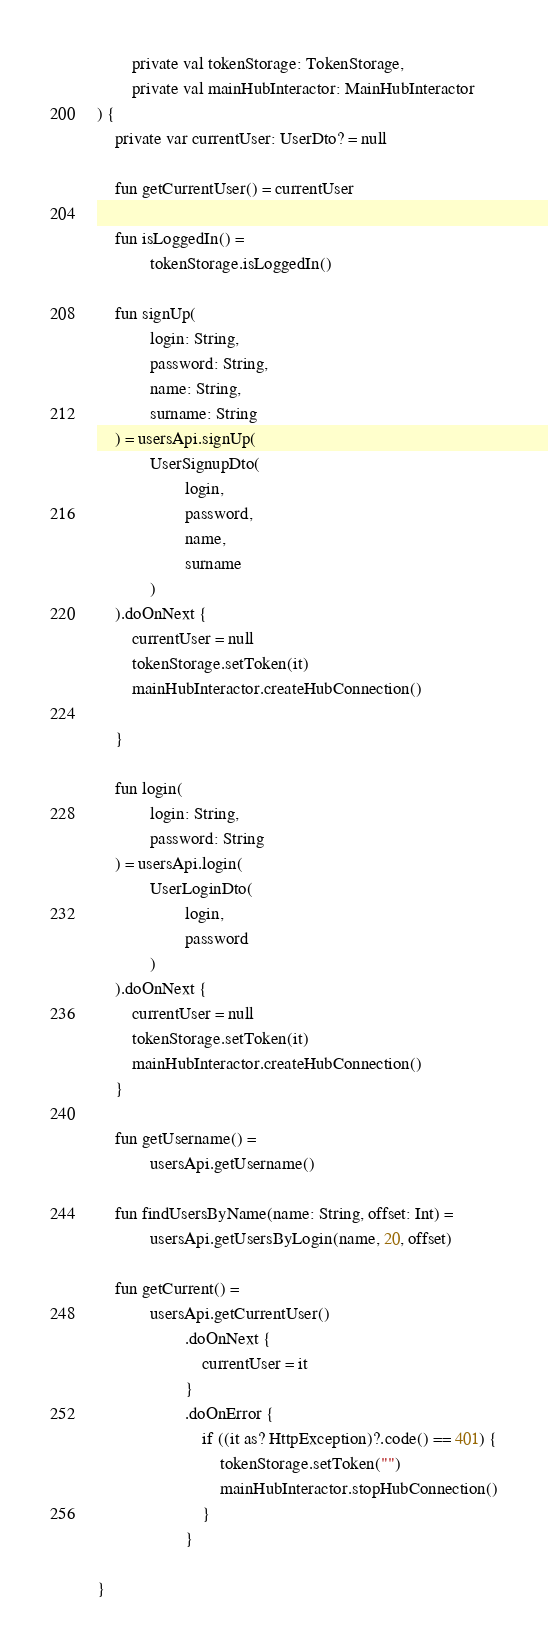Convert code to text. <code><loc_0><loc_0><loc_500><loc_500><_Kotlin_>        private val tokenStorage: TokenStorage,
        private val mainHubInteractor: MainHubInteractor
) {
    private var currentUser: UserDto? = null

    fun getCurrentUser() = currentUser

    fun isLoggedIn() =
            tokenStorage.isLoggedIn()

    fun signUp(
            login: String,
            password: String,
            name: String,
            surname: String
    ) = usersApi.signUp(
            UserSignupDto(
                    login,
                    password,
                    name,
                    surname
            )
    ).doOnNext {
        currentUser = null
        tokenStorage.setToken(it)
        mainHubInteractor.createHubConnection()

    }

    fun login(
            login: String,
            password: String
    ) = usersApi.login(
            UserLoginDto(
                    login,
                    password
            )
    ).doOnNext {
        currentUser = null
        tokenStorage.setToken(it)
        mainHubInteractor.createHubConnection()
    }

    fun getUsername() =
            usersApi.getUsername()

    fun findUsersByName(name: String, offset: Int) =
            usersApi.getUsersByLogin(name, 20, offset)

    fun getCurrent() =
            usersApi.getCurrentUser()
                    .doOnNext {
                        currentUser = it
                    }
                    .doOnError {
                        if ((it as? HttpException)?.code() == 401) {
                            tokenStorage.setToken("")
                            mainHubInteractor.stopHubConnection()
                        }
                    }

}


</code> 